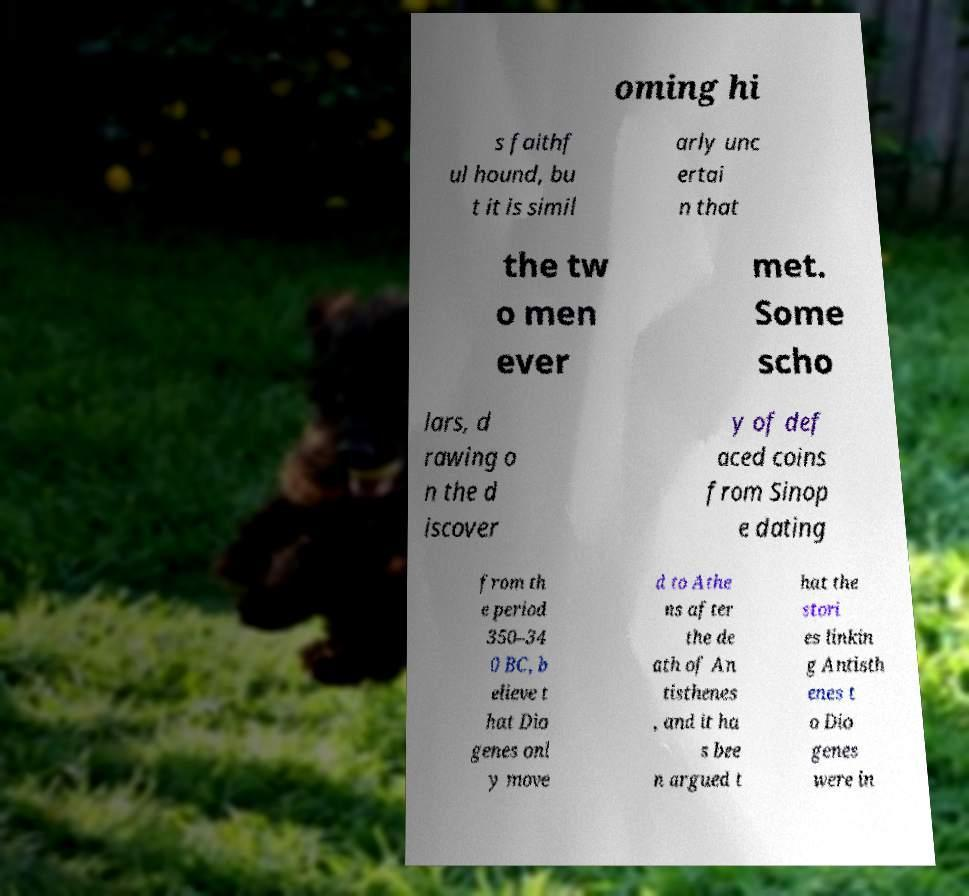Please read and relay the text visible in this image. What does it say? oming hi s faithf ul hound, bu t it is simil arly unc ertai n that the tw o men ever met. Some scho lars, d rawing o n the d iscover y of def aced coins from Sinop e dating from th e period 350–34 0 BC, b elieve t hat Dio genes onl y move d to Athe ns after the de ath of An tisthenes , and it ha s bee n argued t hat the stori es linkin g Antisth enes t o Dio genes were in 